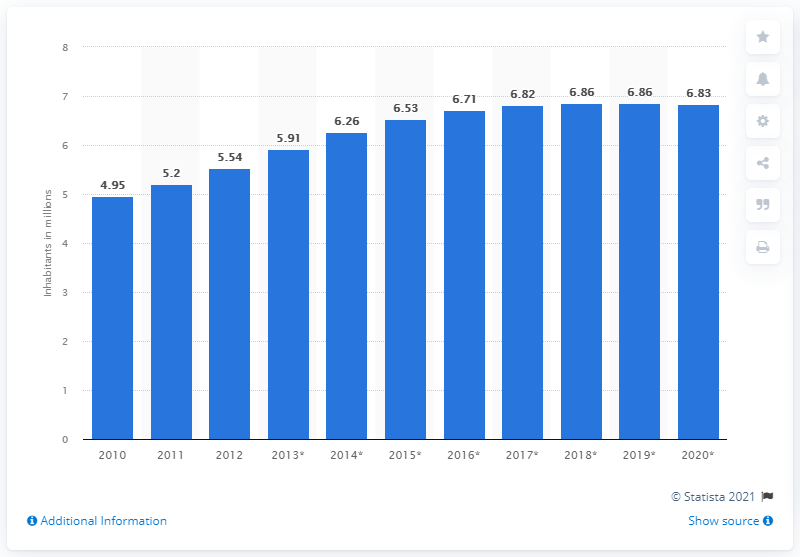Point out several critical features in this image. As of 2020, the population of Lebanon was 6.83 million. 